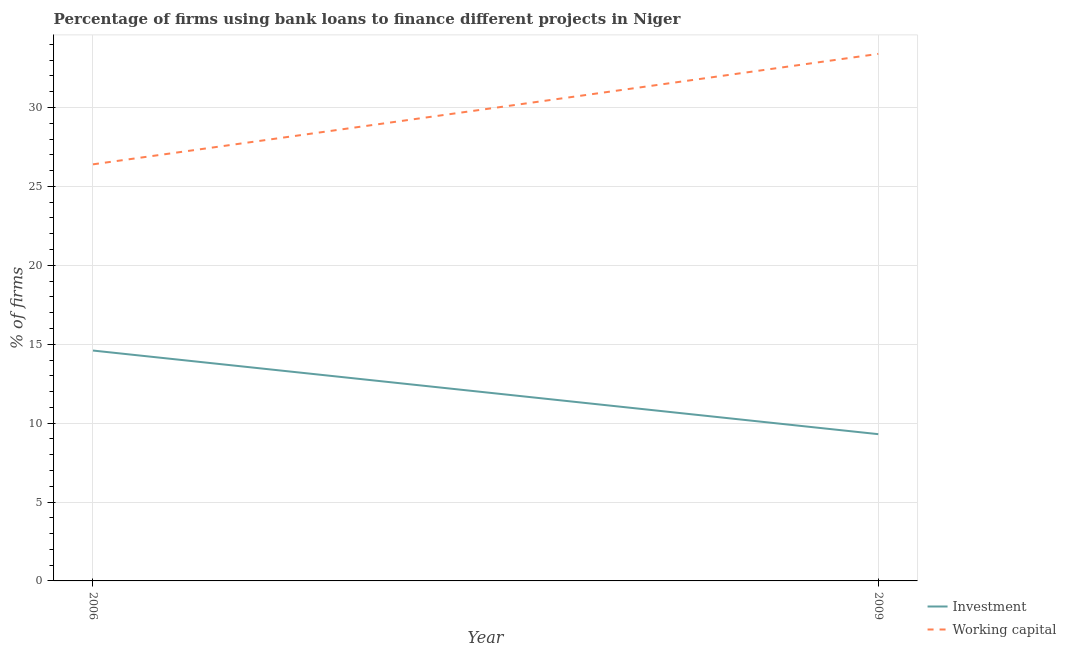Does the line corresponding to percentage of firms using banks to finance investment intersect with the line corresponding to percentage of firms using banks to finance working capital?
Your response must be concise. No. Is the number of lines equal to the number of legend labels?
Your answer should be compact. Yes. Across all years, what is the maximum percentage of firms using banks to finance working capital?
Offer a terse response. 33.4. In which year was the percentage of firms using banks to finance investment maximum?
Your answer should be compact. 2006. In which year was the percentage of firms using banks to finance investment minimum?
Provide a succinct answer. 2009. What is the total percentage of firms using banks to finance investment in the graph?
Provide a succinct answer. 23.9. What is the difference between the percentage of firms using banks to finance working capital in 2009 and the percentage of firms using banks to finance investment in 2006?
Your answer should be very brief. 18.8. What is the average percentage of firms using banks to finance working capital per year?
Give a very brief answer. 29.9. In the year 2006, what is the difference between the percentage of firms using banks to finance investment and percentage of firms using banks to finance working capital?
Provide a succinct answer. -11.8. In how many years, is the percentage of firms using banks to finance working capital greater than 10 %?
Your response must be concise. 2. What is the ratio of the percentage of firms using banks to finance investment in 2006 to that in 2009?
Your answer should be compact. 1.57. Is the percentage of firms using banks to finance investment in 2006 less than that in 2009?
Provide a short and direct response. No. Is the percentage of firms using banks to finance working capital strictly greater than the percentage of firms using banks to finance investment over the years?
Provide a short and direct response. Yes. Is the percentage of firms using banks to finance investment strictly less than the percentage of firms using banks to finance working capital over the years?
Your response must be concise. Yes. How many legend labels are there?
Provide a short and direct response. 2. How are the legend labels stacked?
Ensure brevity in your answer.  Vertical. What is the title of the graph?
Make the answer very short. Percentage of firms using bank loans to finance different projects in Niger. What is the label or title of the X-axis?
Make the answer very short. Year. What is the label or title of the Y-axis?
Ensure brevity in your answer.  % of firms. What is the % of firms of Investment in 2006?
Offer a terse response. 14.6. What is the % of firms of Working capital in 2006?
Your response must be concise. 26.4. What is the % of firms in Investment in 2009?
Offer a very short reply. 9.3. What is the % of firms in Working capital in 2009?
Your response must be concise. 33.4. Across all years, what is the maximum % of firms in Investment?
Offer a very short reply. 14.6. Across all years, what is the maximum % of firms of Working capital?
Make the answer very short. 33.4. Across all years, what is the minimum % of firms of Working capital?
Keep it short and to the point. 26.4. What is the total % of firms in Investment in the graph?
Your response must be concise. 23.9. What is the total % of firms of Working capital in the graph?
Provide a short and direct response. 59.8. What is the difference between the % of firms of Investment in 2006 and that in 2009?
Your response must be concise. 5.3. What is the difference between the % of firms of Working capital in 2006 and that in 2009?
Your answer should be very brief. -7. What is the difference between the % of firms of Investment in 2006 and the % of firms of Working capital in 2009?
Provide a succinct answer. -18.8. What is the average % of firms of Investment per year?
Offer a very short reply. 11.95. What is the average % of firms in Working capital per year?
Make the answer very short. 29.9. In the year 2009, what is the difference between the % of firms in Investment and % of firms in Working capital?
Keep it short and to the point. -24.1. What is the ratio of the % of firms in Investment in 2006 to that in 2009?
Give a very brief answer. 1.57. What is the ratio of the % of firms of Working capital in 2006 to that in 2009?
Provide a short and direct response. 0.79. What is the difference between the highest and the lowest % of firms of Investment?
Ensure brevity in your answer.  5.3. What is the difference between the highest and the lowest % of firms in Working capital?
Make the answer very short. 7. 